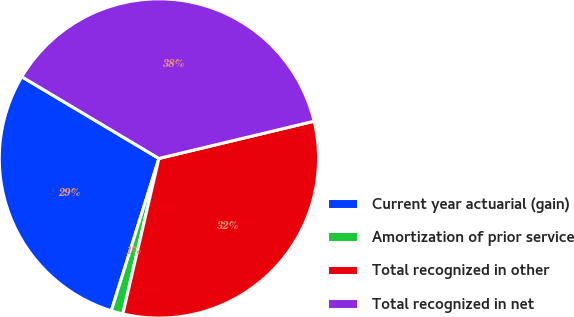Convert chart to OTSL. <chart><loc_0><loc_0><loc_500><loc_500><pie_chart><fcel>Current year actuarial (gain)<fcel>Amortization of prior service<fcel>Total recognized in other<fcel>Total recognized in net<nl><fcel>28.73%<fcel>1.19%<fcel>32.38%<fcel>37.7%<nl></chart> 